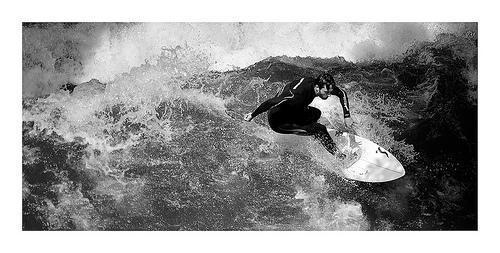How many surfboards are in the water?
Give a very brief answer. 1. How many people are surfing?
Give a very brief answer. 1. How many arms are visible?
Give a very brief answer. 2. How many people are pictured?
Give a very brief answer. 1. 